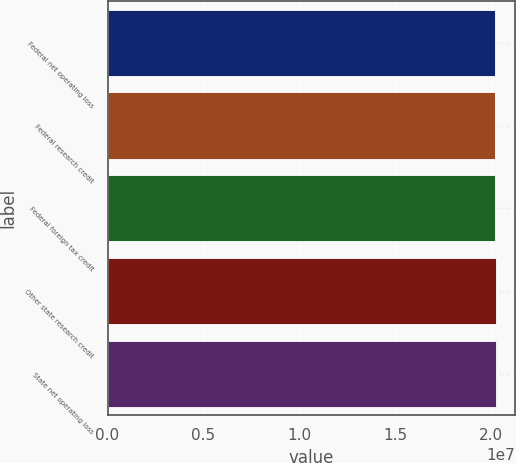<chart> <loc_0><loc_0><loc_500><loc_500><bar_chart><fcel>Federal net operating loss<fcel>Federal research credit<fcel>Federal foreign tax credit<fcel>Other state research credit<fcel>State net operating loss<nl><fcel>2.0182e+07<fcel>2.0198e+07<fcel>2.0192e+07<fcel>2.0232e+07<fcel>2.0242e+07<nl></chart> 